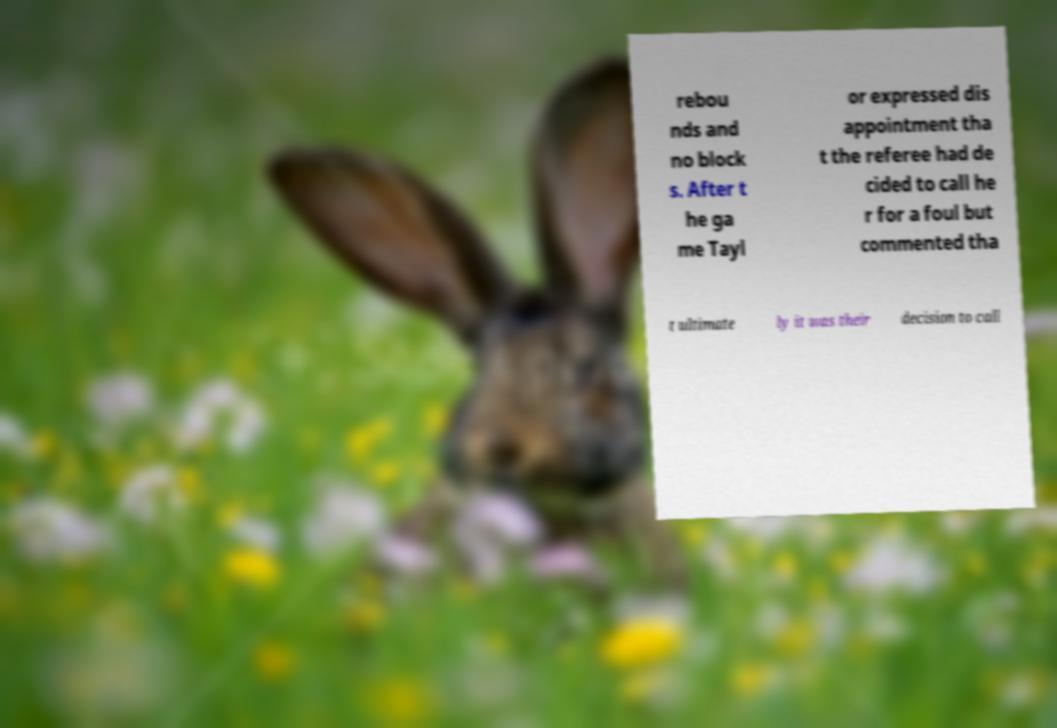Please identify and transcribe the text found in this image. rebou nds and no block s. After t he ga me Tayl or expressed dis appointment tha t the referee had de cided to call he r for a foul but commented tha t ultimate ly it was their decision to call 